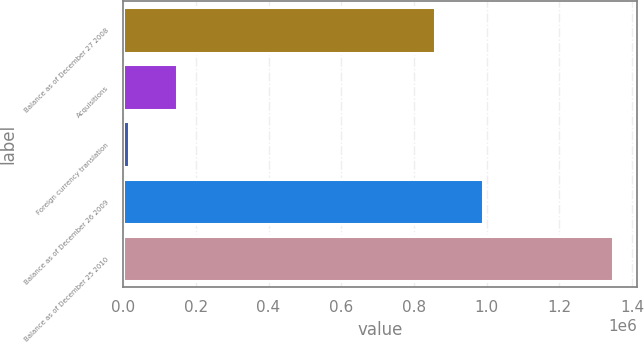<chart> <loc_0><loc_0><loc_500><loc_500><bar_chart><fcel>Balance as of December 27 2008<fcel>Acquisitions<fcel>Foreign currency translation<fcel>Balance as of December 26 2009<fcel>Balance as of December 25 2010<nl><fcel>856623<fcel>148789<fcel>15674<fcel>989738<fcel>1.34682e+06<nl></chart> 